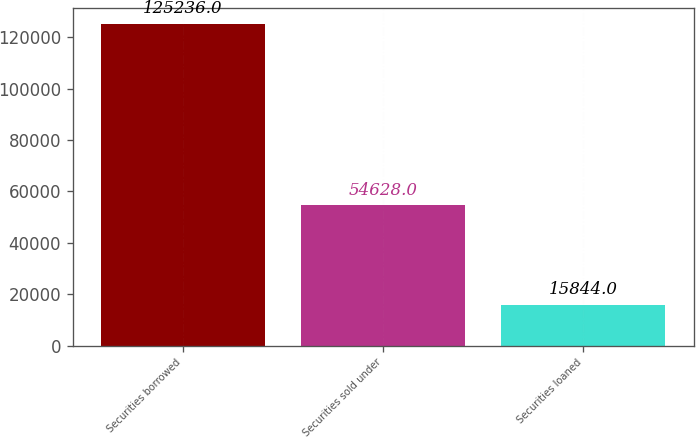Convert chart. <chart><loc_0><loc_0><loc_500><loc_500><bar_chart><fcel>Securities borrowed<fcel>Securities sold under<fcel>Securities loaned<nl><fcel>125236<fcel>54628<fcel>15844<nl></chart> 